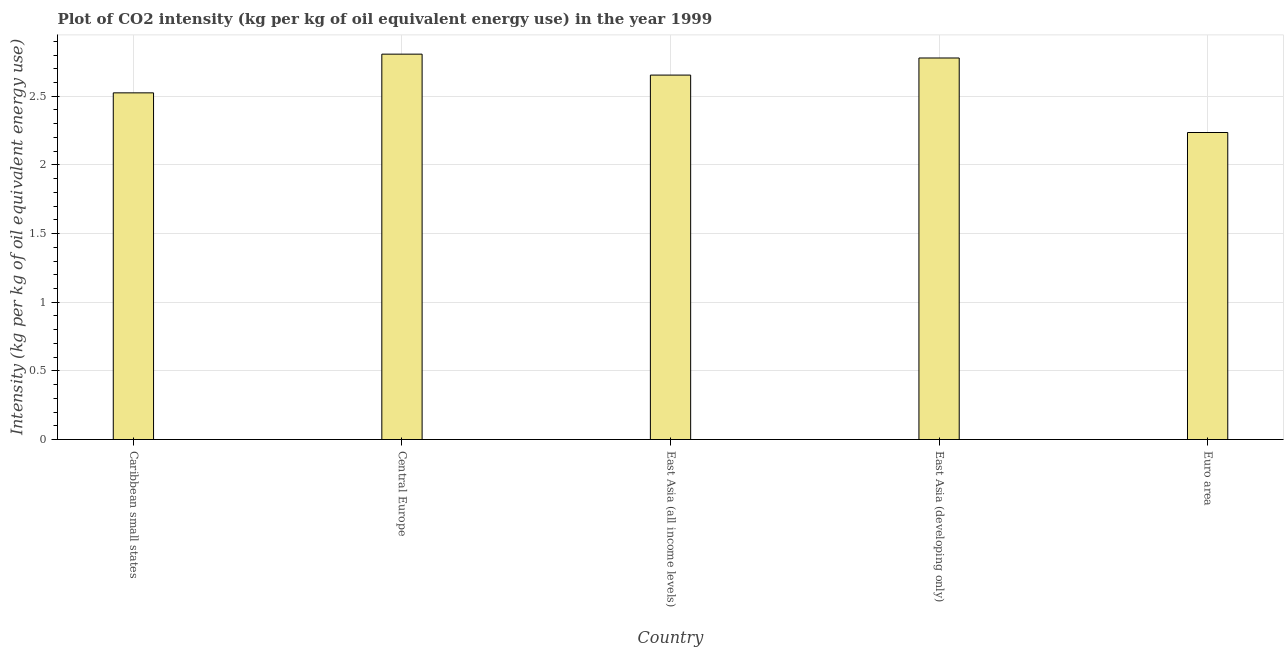Does the graph contain any zero values?
Your answer should be compact. No. Does the graph contain grids?
Provide a short and direct response. Yes. What is the title of the graph?
Provide a succinct answer. Plot of CO2 intensity (kg per kg of oil equivalent energy use) in the year 1999. What is the label or title of the X-axis?
Offer a very short reply. Country. What is the label or title of the Y-axis?
Provide a short and direct response. Intensity (kg per kg of oil equivalent energy use). What is the co2 intensity in Caribbean small states?
Your answer should be compact. 2.52. Across all countries, what is the maximum co2 intensity?
Your answer should be very brief. 2.81. Across all countries, what is the minimum co2 intensity?
Give a very brief answer. 2.24. In which country was the co2 intensity maximum?
Provide a succinct answer. Central Europe. What is the sum of the co2 intensity?
Keep it short and to the point. 13. What is the difference between the co2 intensity in East Asia (all income levels) and Euro area?
Offer a terse response. 0.42. What is the median co2 intensity?
Offer a very short reply. 2.65. What is the ratio of the co2 intensity in East Asia (all income levels) to that in Euro area?
Ensure brevity in your answer.  1.19. What is the difference between the highest and the second highest co2 intensity?
Give a very brief answer. 0.03. Is the sum of the co2 intensity in Caribbean small states and East Asia (developing only) greater than the maximum co2 intensity across all countries?
Give a very brief answer. Yes. What is the difference between the highest and the lowest co2 intensity?
Offer a very short reply. 0.57. What is the difference between two consecutive major ticks on the Y-axis?
Your answer should be compact. 0.5. Are the values on the major ticks of Y-axis written in scientific E-notation?
Your answer should be compact. No. What is the Intensity (kg per kg of oil equivalent energy use) of Caribbean small states?
Your response must be concise. 2.52. What is the Intensity (kg per kg of oil equivalent energy use) in Central Europe?
Offer a very short reply. 2.81. What is the Intensity (kg per kg of oil equivalent energy use) in East Asia (all income levels)?
Provide a succinct answer. 2.65. What is the Intensity (kg per kg of oil equivalent energy use) of East Asia (developing only)?
Give a very brief answer. 2.78. What is the Intensity (kg per kg of oil equivalent energy use) in Euro area?
Provide a short and direct response. 2.24. What is the difference between the Intensity (kg per kg of oil equivalent energy use) in Caribbean small states and Central Europe?
Make the answer very short. -0.28. What is the difference between the Intensity (kg per kg of oil equivalent energy use) in Caribbean small states and East Asia (all income levels)?
Offer a very short reply. -0.13. What is the difference between the Intensity (kg per kg of oil equivalent energy use) in Caribbean small states and East Asia (developing only)?
Provide a succinct answer. -0.25. What is the difference between the Intensity (kg per kg of oil equivalent energy use) in Caribbean small states and Euro area?
Ensure brevity in your answer.  0.29. What is the difference between the Intensity (kg per kg of oil equivalent energy use) in Central Europe and East Asia (all income levels)?
Ensure brevity in your answer.  0.15. What is the difference between the Intensity (kg per kg of oil equivalent energy use) in Central Europe and East Asia (developing only)?
Provide a succinct answer. 0.03. What is the difference between the Intensity (kg per kg of oil equivalent energy use) in Central Europe and Euro area?
Keep it short and to the point. 0.57. What is the difference between the Intensity (kg per kg of oil equivalent energy use) in East Asia (all income levels) and East Asia (developing only)?
Keep it short and to the point. -0.12. What is the difference between the Intensity (kg per kg of oil equivalent energy use) in East Asia (all income levels) and Euro area?
Ensure brevity in your answer.  0.42. What is the difference between the Intensity (kg per kg of oil equivalent energy use) in East Asia (developing only) and Euro area?
Your response must be concise. 0.54. What is the ratio of the Intensity (kg per kg of oil equivalent energy use) in Caribbean small states to that in East Asia (all income levels)?
Your answer should be very brief. 0.95. What is the ratio of the Intensity (kg per kg of oil equivalent energy use) in Caribbean small states to that in East Asia (developing only)?
Give a very brief answer. 0.91. What is the ratio of the Intensity (kg per kg of oil equivalent energy use) in Caribbean small states to that in Euro area?
Your answer should be very brief. 1.13. What is the ratio of the Intensity (kg per kg of oil equivalent energy use) in Central Europe to that in East Asia (all income levels)?
Your answer should be compact. 1.06. What is the ratio of the Intensity (kg per kg of oil equivalent energy use) in Central Europe to that in East Asia (developing only)?
Your answer should be compact. 1.01. What is the ratio of the Intensity (kg per kg of oil equivalent energy use) in Central Europe to that in Euro area?
Your response must be concise. 1.25. What is the ratio of the Intensity (kg per kg of oil equivalent energy use) in East Asia (all income levels) to that in East Asia (developing only)?
Your answer should be very brief. 0.95. What is the ratio of the Intensity (kg per kg of oil equivalent energy use) in East Asia (all income levels) to that in Euro area?
Keep it short and to the point. 1.19. What is the ratio of the Intensity (kg per kg of oil equivalent energy use) in East Asia (developing only) to that in Euro area?
Offer a very short reply. 1.24. 